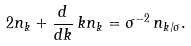<formula> <loc_0><loc_0><loc_500><loc_500>2 n _ { k } + \frac { d } { d k } \, k n _ { k } = \sigma ^ { - 2 } \, n _ { k / \sigma } .</formula> 